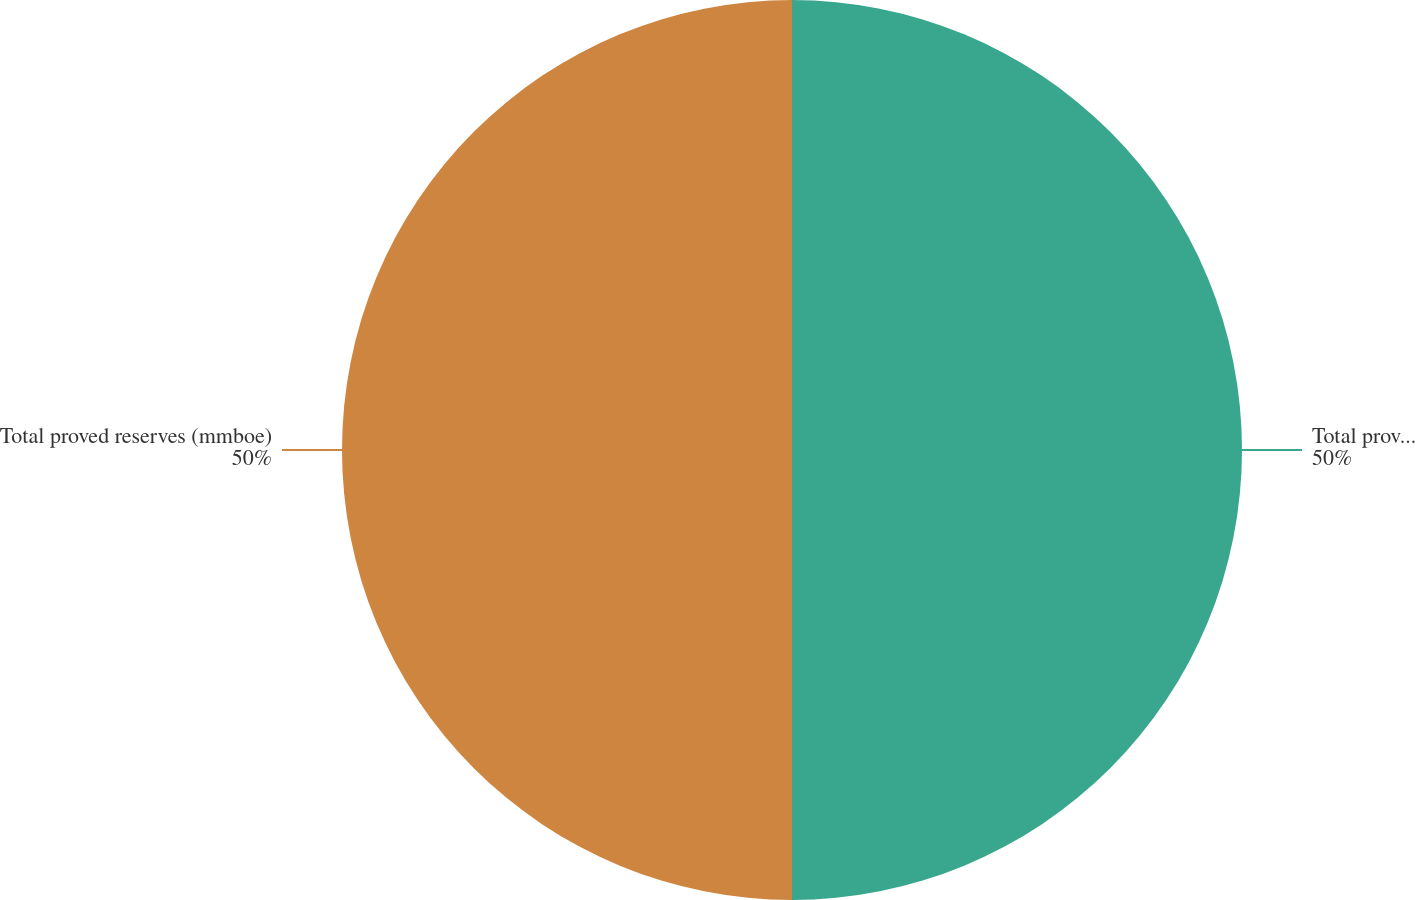<chart> <loc_0><loc_0><loc_500><loc_500><pie_chart><fcel>Total proved developed<fcel>Total proved reserves (mmboe)<nl><fcel>50.0%<fcel>50.0%<nl></chart> 